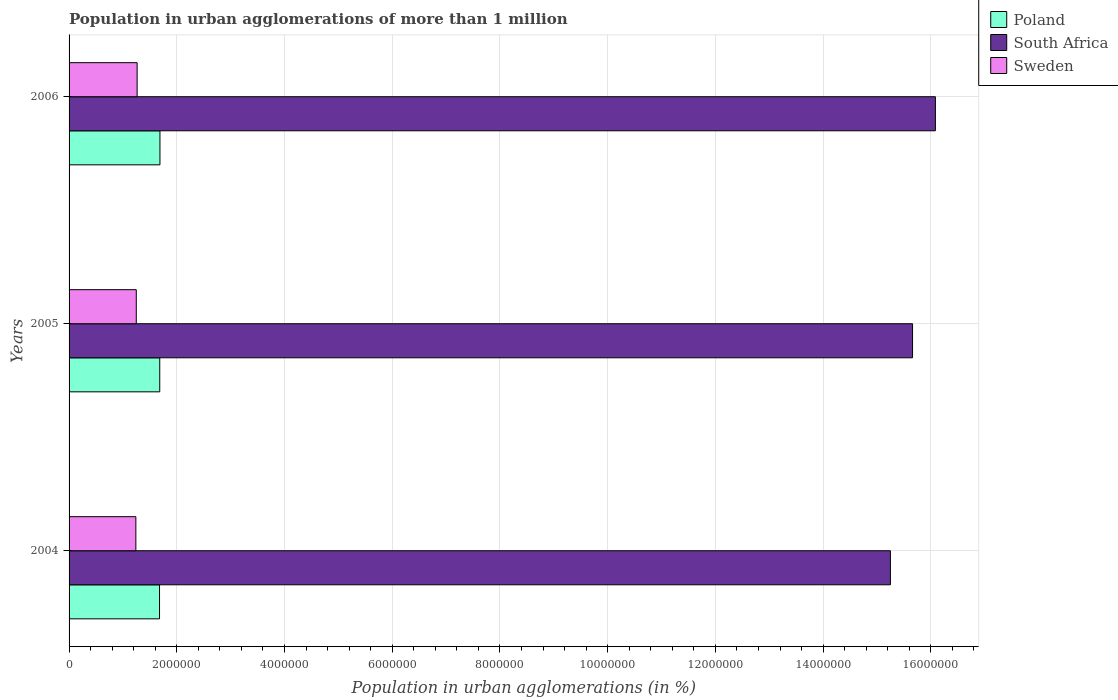How many different coloured bars are there?
Make the answer very short. 3. How many groups of bars are there?
Your response must be concise. 3. Are the number of bars on each tick of the Y-axis equal?
Provide a short and direct response. Yes. How many bars are there on the 3rd tick from the top?
Your answer should be very brief. 3. What is the label of the 1st group of bars from the top?
Provide a short and direct response. 2006. What is the population in urban agglomerations in Poland in 2004?
Provide a short and direct response. 1.68e+06. Across all years, what is the maximum population in urban agglomerations in Poland?
Ensure brevity in your answer.  1.69e+06. Across all years, what is the minimum population in urban agglomerations in South Africa?
Provide a succinct answer. 1.52e+07. In which year was the population in urban agglomerations in Sweden maximum?
Ensure brevity in your answer.  2006. What is the total population in urban agglomerations in South Africa in the graph?
Your answer should be compact. 4.70e+07. What is the difference between the population in urban agglomerations in Poland in 2005 and that in 2006?
Your response must be concise. -3818. What is the difference between the population in urban agglomerations in South Africa in 2006 and the population in urban agglomerations in Poland in 2005?
Your answer should be compact. 1.44e+07. What is the average population in urban agglomerations in Poland per year?
Provide a succinct answer. 1.68e+06. In the year 2006, what is the difference between the population in urban agglomerations in Sweden and population in urban agglomerations in South Africa?
Keep it short and to the point. -1.48e+07. In how many years, is the population in urban agglomerations in Poland greater than 13200000 %?
Provide a short and direct response. 0. What is the ratio of the population in urban agglomerations in Sweden in 2005 to that in 2006?
Your answer should be very brief. 0.99. What is the difference between the highest and the second highest population in urban agglomerations in Sweden?
Ensure brevity in your answer.  1.56e+04. What is the difference between the highest and the lowest population in urban agglomerations in Poland?
Make the answer very short. 7623. In how many years, is the population in urban agglomerations in Sweden greater than the average population in urban agglomerations in Sweden taken over all years?
Your answer should be very brief. 1. Is the sum of the population in urban agglomerations in Poland in 2004 and 2005 greater than the maximum population in urban agglomerations in South Africa across all years?
Your answer should be compact. No. What does the 3rd bar from the top in 2005 represents?
Offer a very short reply. Poland. What does the 3rd bar from the bottom in 2004 represents?
Offer a terse response. Sweden. Are all the bars in the graph horizontal?
Provide a succinct answer. Yes. How many years are there in the graph?
Give a very brief answer. 3. Are the values on the major ticks of X-axis written in scientific E-notation?
Make the answer very short. No. Does the graph contain any zero values?
Offer a very short reply. No. Does the graph contain grids?
Give a very brief answer. Yes. Where does the legend appear in the graph?
Offer a very short reply. Top right. How are the legend labels stacked?
Your answer should be very brief. Vertical. What is the title of the graph?
Your answer should be very brief. Population in urban agglomerations of more than 1 million. Does "Niger" appear as one of the legend labels in the graph?
Your response must be concise. No. What is the label or title of the X-axis?
Give a very brief answer. Population in urban agglomerations (in %). What is the Population in urban agglomerations (in %) in Poland in 2004?
Provide a short and direct response. 1.68e+06. What is the Population in urban agglomerations (in %) in South Africa in 2004?
Your answer should be very brief. 1.52e+07. What is the Population in urban agglomerations (in %) in Sweden in 2004?
Provide a succinct answer. 1.24e+06. What is the Population in urban agglomerations (in %) of Poland in 2005?
Give a very brief answer. 1.68e+06. What is the Population in urban agglomerations (in %) of South Africa in 2005?
Offer a very short reply. 1.57e+07. What is the Population in urban agglomerations (in %) of Sweden in 2005?
Your answer should be compact. 1.25e+06. What is the Population in urban agglomerations (in %) in Poland in 2006?
Provide a succinct answer. 1.69e+06. What is the Population in urban agglomerations (in %) in South Africa in 2006?
Provide a short and direct response. 1.61e+07. What is the Population in urban agglomerations (in %) of Sweden in 2006?
Provide a succinct answer. 1.26e+06. Across all years, what is the maximum Population in urban agglomerations (in %) in Poland?
Provide a short and direct response. 1.69e+06. Across all years, what is the maximum Population in urban agglomerations (in %) in South Africa?
Provide a succinct answer. 1.61e+07. Across all years, what is the maximum Population in urban agglomerations (in %) in Sweden?
Offer a very short reply. 1.26e+06. Across all years, what is the minimum Population in urban agglomerations (in %) of Poland?
Ensure brevity in your answer.  1.68e+06. Across all years, what is the minimum Population in urban agglomerations (in %) of South Africa?
Give a very brief answer. 1.52e+07. Across all years, what is the minimum Population in urban agglomerations (in %) of Sweden?
Give a very brief answer. 1.24e+06. What is the total Population in urban agglomerations (in %) of Poland in the graph?
Offer a terse response. 5.05e+06. What is the total Population in urban agglomerations (in %) in South Africa in the graph?
Your response must be concise. 4.70e+07. What is the total Population in urban agglomerations (in %) in Sweden in the graph?
Provide a short and direct response. 3.75e+06. What is the difference between the Population in urban agglomerations (in %) of Poland in 2004 and that in 2005?
Provide a succinct answer. -3805. What is the difference between the Population in urban agglomerations (in %) of South Africa in 2004 and that in 2005?
Offer a terse response. -4.11e+05. What is the difference between the Population in urban agglomerations (in %) of Sweden in 2004 and that in 2005?
Keep it short and to the point. -8031. What is the difference between the Population in urban agglomerations (in %) in Poland in 2004 and that in 2006?
Your answer should be compact. -7623. What is the difference between the Population in urban agglomerations (in %) in South Africa in 2004 and that in 2006?
Your answer should be compact. -8.35e+05. What is the difference between the Population in urban agglomerations (in %) of Sweden in 2004 and that in 2006?
Provide a succinct answer. -2.36e+04. What is the difference between the Population in urban agglomerations (in %) in Poland in 2005 and that in 2006?
Offer a terse response. -3818. What is the difference between the Population in urban agglomerations (in %) of South Africa in 2005 and that in 2006?
Your answer should be very brief. -4.24e+05. What is the difference between the Population in urban agglomerations (in %) in Sweden in 2005 and that in 2006?
Provide a succinct answer. -1.56e+04. What is the difference between the Population in urban agglomerations (in %) in Poland in 2004 and the Population in urban agglomerations (in %) in South Africa in 2005?
Give a very brief answer. -1.40e+07. What is the difference between the Population in urban agglomerations (in %) of Poland in 2004 and the Population in urban agglomerations (in %) of Sweden in 2005?
Keep it short and to the point. 4.32e+05. What is the difference between the Population in urban agglomerations (in %) of South Africa in 2004 and the Population in urban agglomerations (in %) of Sweden in 2005?
Your answer should be compact. 1.40e+07. What is the difference between the Population in urban agglomerations (in %) in Poland in 2004 and the Population in urban agglomerations (in %) in South Africa in 2006?
Your answer should be very brief. -1.44e+07. What is the difference between the Population in urban agglomerations (in %) of Poland in 2004 and the Population in urban agglomerations (in %) of Sweden in 2006?
Offer a very short reply. 4.16e+05. What is the difference between the Population in urban agglomerations (in %) of South Africa in 2004 and the Population in urban agglomerations (in %) of Sweden in 2006?
Offer a very short reply. 1.40e+07. What is the difference between the Population in urban agglomerations (in %) in Poland in 2005 and the Population in urban agglomerations (in %) in South Africa in 2006?
Make the answer very short. -1.44e+07. What is the difference between the Population in urban agglomerations (in %) in Poland in 2005 and the Population in urban agglomerations (in %) in Sweden in 2006?
Ensure brevity in your answer.  4.20e+05. What is the difference between the Population in urban agglomerations (in %) in South Africa in 2005 and the Population in urban agglomerations (in %) in Sweden in 2006?
Offer a very short reply. 1.44e+07. What is the average Population in urban agglomerations (in %) in Poland per year?
Give a very brief answer. 1.68e+06. What is the average Population in urban agglomerations (in %) in South Africa per year?
Your response must be concise. 1.57e+07. What is the average Population in urban agglomerations (in %) of Sweden per year?
Provide a short and direct response. 1.25e+06. In the year 2004, what is the difference between the Population in urban agglomerations (in %) of Poland and Population in urban agglomerations (in %) of South Africa?
Make the answer very short. -1.36e+07. In the year 2004, what is the difference between the Population in urban agglomerations (in %) in Poland and Population in urban agglomerations (in %) in Sweden?
Offer a terse response. 4.40e+05. In the year 2004, what is the difference between the Population in urban agglomerations (in %) of South Africa and Population in urban agglomerations (in %) of Sweden?
Your answer should be very brief. 1.40e+07. In the year 2005, what is the difference between the Population in urban agglomerations (in %) in Poland and Population in urban agglomerations (in %) in South Africa?
Make the answer very short. -1.40e+07. In the year 2005, what is the difference between the Population in urban agglomerations (in %) in Poland and Population in urban agglomerations (in %) in Sweden?
Your answer should be compact. 4.36e+05. In the year 2005, what is the difference between the Population in urban agglomerations (in %) in South Africa and Population in urban agglomerations (in %) in Sweden?
Your response must be concise. 1.44e+07. In the year 2006, what is the difference between the Population in urban agglomerations (in %) in Poland and Population in urban agglomerations (in %) in South Africa?
Ensure brevity in your answer.  -1.44e+07. In the year 2006, what is the difference between the Population in urban agglomerations (in %) in Poland and Population in urban agglomerations (in %) in Sweden?
Your answer should be very brief. 4.24e+05. In the year 2006, what is the difference between the Population in urban agglomerations (in %) in South Africa and Population in urban agglomerations (in %) in Sweden?
Offer a very short reply. 1.48e+07. What is the ratio of the Population in urban agglomerations (in %) in South Africa in 2004 to that in 2005?
Your answer should be compact. 0.97. What is the ratio of the Population in urban agglomerations (in %) of South Africa in 2004 to that in 2006?
Your answer should be very brief. 0.95. What is the ratio of the Population in urban agglomerations (in %) of Sweden in 2004 to that in 2006?
Offer a very short reply. 0.98. What is the ratio of the Population in urban agglomerations (in %) of Poland in 2005 to that in 2006?
Keep it short and to the point. 1. What is the ratio of the Population in urban agglomerations (in %) of South Africa in 2005 to that in 2006?
Offer a very short reply. 0.97. What is the ratio of the Population in urban agglomerations (in %) of Sweden in 2005 to that in 2006?
Your response must be concise. 0.99. What is the difference between the highest and the second highest Population in urban agglomerations (in %) in Poland?
Offer a terse response. 3818. What is the difference between the highest and the second highest Population in urban agglomerations (in %) in South Africa?
Your answer should be compact. 4.24e+05. What is the difference between the highest and the second highest Population in urban agglomerations (in %) in Sweden?
Your answer should be compact. 1.56e+04. What is the difference between the highest and the lowest Population in urban agglomerations (in %) of Poland?
Your response must be concise. 7623. What is the difference between the highest and the lowest Population in urban agglomerations (in %) of South Africa?
Give a very brief answer. 8.35e+05. What is the difference between the highest and the lowest Population in urban agglomerations (in %) of Sweden?
Give a very brief answer. 2.36e+04. 